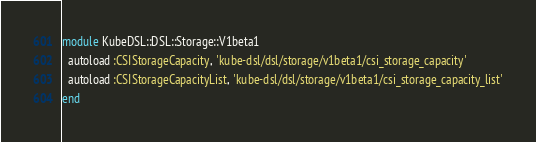<code> <loc_0><loc_0><loc_500><loc_500><_Ruby_>module KubeDSL::DSL::Storage::V1beta1
  autoload :CSIStorageCapacity, 'kube-dsl/dsl/storage/v1beta1/csi_storage_capacity'
  autoload :CSIStorageCapacityList, 'kube-dsl/dsl/storage/v1beta1/csi_storage_capacity_list'
end
</code> 